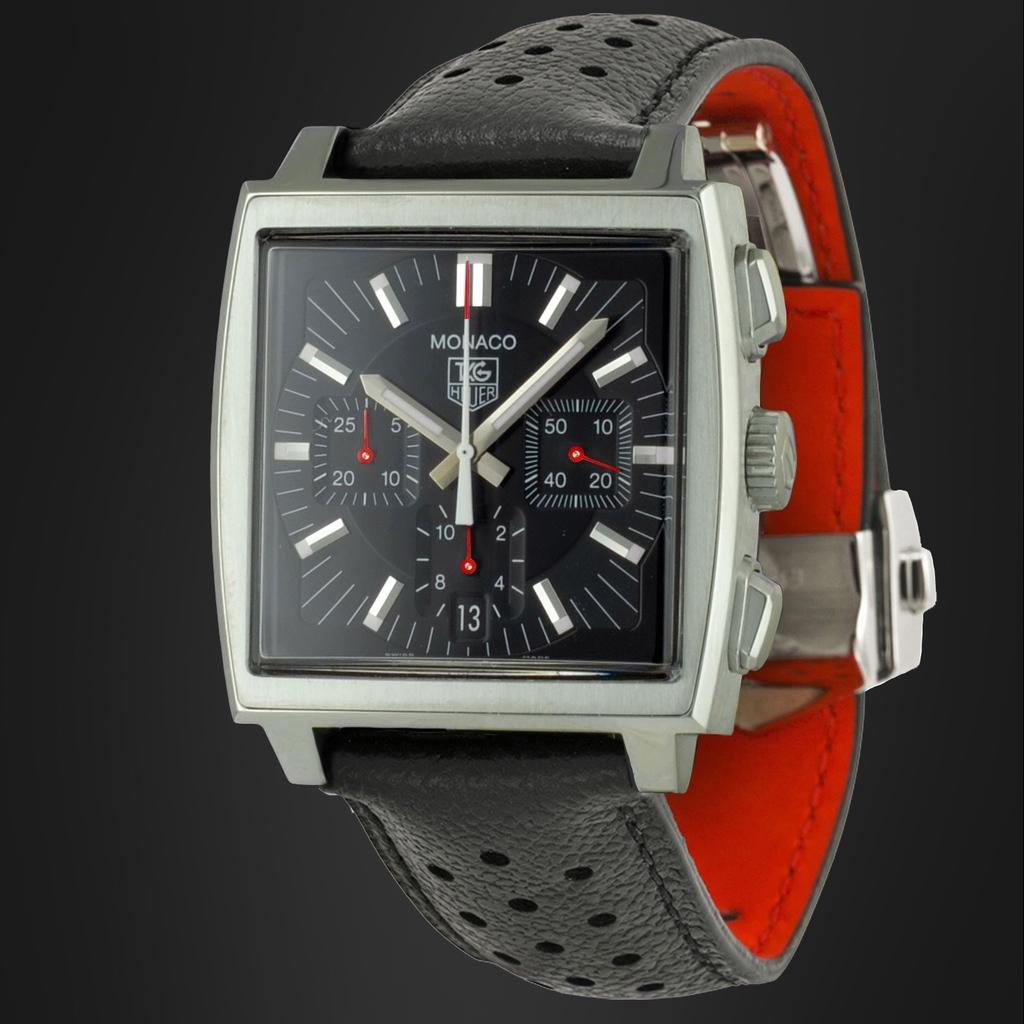About what time is it?
Give a very brief answer. 10:07. Huelga general product?
Provide a short and direct response. Unanswerable. 